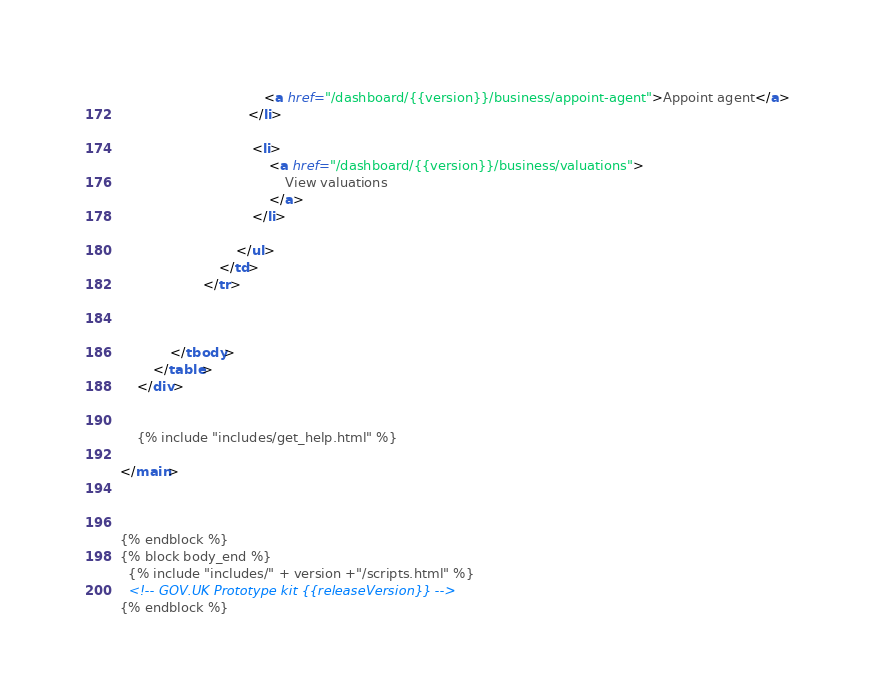<code> <loc_0><loc_0><loc_500><loc_500><_HTML_>                                   <a href="/dashboard/{{version}}/business/appoint-agent">Appoint agent</a>
                               </li>

                                <li>
                                    <a href="/dashboard/{{version}}/business/valuations">
                                        View valuations
                                    </a>
                                </li>

                            </ul>
                        </td>
                    </tr>



            </tbody>
        </table>
    </div>


    {% include "includes/get_help.html" %}

</main>



{% endblock %}
{% block body_end %}
  {% include "includes/" + version +"/scripts.html" %}
  <!-- GOV.UK Prototype kit {{releaseVersion}} -->
{% endblock %}
</code> 